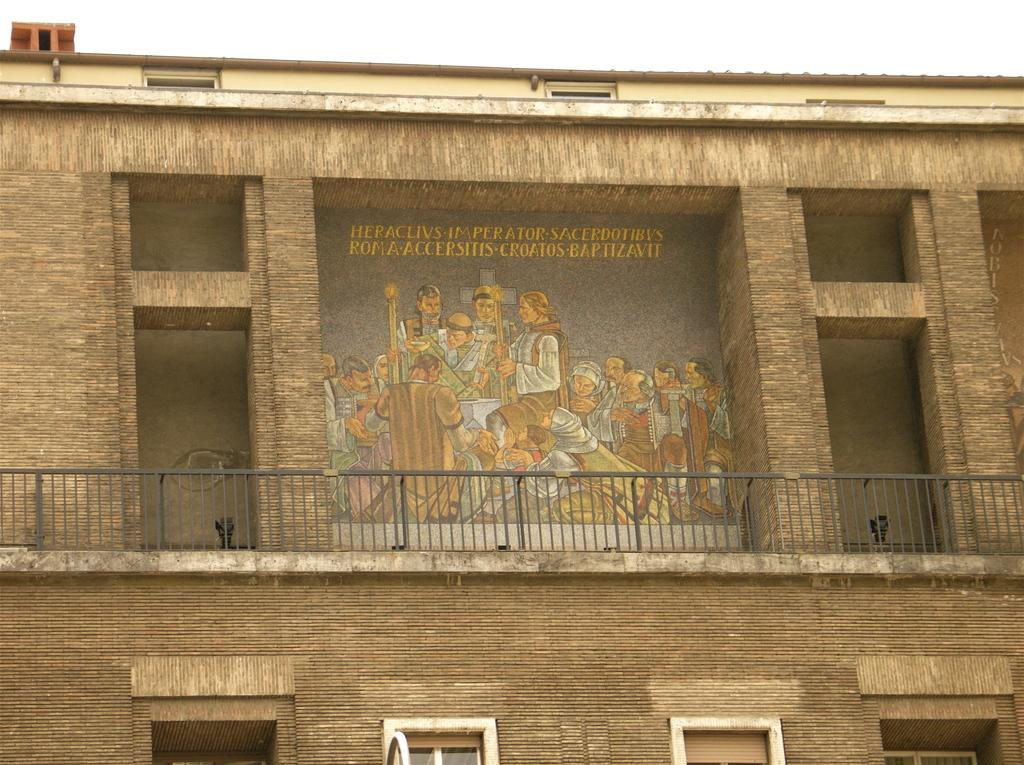What type of structure is visible in the image? There is a building in the image. What is surrounding the building? There is fencing in the image. What type of material is used for the windows of the building? There are glass windows in the image. Are there any people present in the image? Yes, there are people in the image. What is one person doing in the image? One person is sitting and holding something. What type of stick is being used by the people in the image? There is no stick visible in the image. Can you see any planes flying in the sky in the image? There is no mention of planes or a sky in the image. 